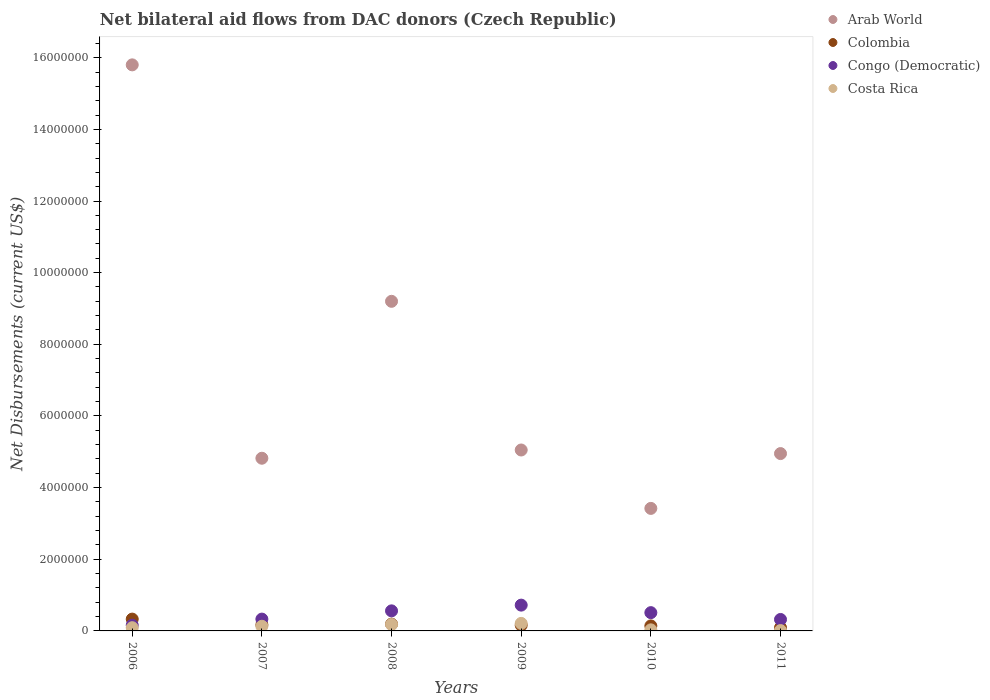What is the net bilateral aid flows in Arab World in 2008?
Offer a very short reply. 9.20e+06. Across all years, what is the maximum net bilateral aid flows in Congo (Democratic)?
Give a very brief answer. 7.20e+05. Across all years, what is the minimum net bilateral aid flows in Arab World?
Your answer should be compact. 3.42e+06. What is the total net bilateral aid flows in Arab World in the graph?
Make the answer very short. 4.32e+07. What is the difference between the net bilateral aid flows in Arab World in 2009 and that in 2011?
Offer a terse response. 1.00e+05. What is the average net bilateral aid flows in Arab World per year?
Give a very brief answer. 7.21e+06. In the year 2006, what is the difference between the net bilateral aid flows in Colombia and net bilateral aid flows in Costa Rica?
Keep it short and to the point. 2.40e+05. Is the difference between the net bilateral aid flows in Colombia in 2008 and 2011 greater than the difference between the net bilateral aid flows in Costa Rica in 2008 and 2011?
Give a very brief answer. No. What is the difference between the highest and the lowest net bilateral aid flows in Congo (Democratic)?
Your answer should be very brief. 5.60e+05. Is it the case that in every year, the sum of the net bilateral aid flows in Costa Rica and net bilateral aid flows in Colombia  is greater than the net bilateral aid flows in Congo (Democratic)?
Keep it short and to the point. No. Does the net bilateral aid flows in Arab World monotonically increase over the years?
Your answer should be very brief. No. How many dotlines are there?
Give a very brief answer. 4. How many years are there in the graph?
Make the answer very short. 6. Are the values on the major ticks of Y-axis written in scientific E-notation?
Ensure brevity in your answer.  No. Does the graph contain any zero values?
Provide a short and direct response. No. Does the graph contain grids?
Your response must be concise. No. What is the title of the graph?
Offer a terse response. Net bilateral aid flows from DAC donors (Czech Republic). What is the label or title of the X-axis?
Provide a short and direct response. Years. What is the label or title of the Y-axis?
Ensure brevity in your answer.  Net Disbursements (current US$). What is the Net Disbursements (current US$) of Arab World in 2006?
Give a very brief answer. 1.58e+07. What is the Net Disbursements (current US$) in Costa Rica in 2006?
Provide a succinct answer. 9.00e+04. What is the Net Disbursements (current US$) in Arab World in 2007?
Your response must be concise. 4.82e+06. What is the Net Disbursements (current US$) of Colombia in 2007?
Offer a terse response. 1.70e+05. What is the Net Disbursements (current US$) in Arab World in 2008?
Make the answer very short. 9.20e+06. What is the Net Disbursements (current US$) in Congo (Democratic) in 2008?
Your response must be concise. 5.60e+05. What is the Net Disbursements (current US$) in Arab World in 2009?
Provide a succinct answer. 5.05e+06. What is the Net Disbursements (current US$) of Colombia in 2009?
Your answer should be very brief. 1.60e+05. What is the Net Disbursements (current US$) in Congo (Democratic) in 2009?
Provide a succinct answer. 7.20e+05. What is the Net Disbursements (current US$) of Costa Rica in 2009?
Your answer should be compact. 2.10e+05. What is the Net Disbursements (current US$) in Arab World in 2010?
Provide a short and direct response. 3.42e+06. What is the Net Disbursements (current US$) in Congo (Democratic) in 2010?
Make the answer very short. 5.10e+05. What is the Net Disbursements (current US$) of Costa Rica in 2010?
Your answer should be very brief. 3.00e+04. What is the Net Disbursements (current US$) in Arab World in 2011?
Your answer should be very brief. 4.95e+06. Across all years, what is the maximum Net Disbursements (current US$) of Arab World?
Provide a succinct answer. 1.58e+07. Across all years, what is the maximum Net Disbursements (current US$) in Colombia?
Your answer should be compact. 3.30e+05. Across all years, what is the maximum Net Disbursements (current US$) of Congo (Democratic)?
Make the answer very short. 7.20e+05. Across all years, what is the minimum Net Disbursements (current US$) in Arab World?
Your response must be concise. 3.42e+06. Across all years, what is the minimum Net Disbursements (current US$) of Colombia?
Give a very brief answer. 9.00e+04. Across all years, what is the minimum Net Disbursements (current US$) in Congo (Democratic)?
Your answer should be compact. 1.60e+05. Across all years, what is the minimum Net Disbursements (current US$) in Costa Rica?
Your response must be concise. 10000. What is the total Net Disbursements (current US$) in Arab World in the graph?
Your answer should be compact. 4.32e+07. What is the total Net Disbursements (current US$) of Colombia in the graph?
Give a very brief answer. 1.08e+06. What is the total Net Disbursements (current US$) of Congo (Democratic) in the graph?
Your response must be concise. 2.60e+06. What is the total Net Disbursements (current US$) of Costa Rica in the graph?
Offer a terse response. 6.50e+05. What is the difference between the Net Disbursements (current US$) in Arab World in 2006 and that in 2007?
Your answer should be compact. 1.10e+07. What is the difference between the Net Disbursements (current US$) in Colombia in 2006 and that in 2007?
Make the answer very short. 1.60e+05. What is the difference between the Net Disbursements (current US$) in Costa Rica in 2006 and that in 2007?
Provide a short and direct response. -4.00e+04. What is the difference between the Net Disbursements (current US$) of Arab World in 2006 and that in 2008?
Provide a short and direct response. 6.60e+06. What is the difference between the Net Disbursements (current US$) in Colombia in 2006 and that in 2008?
Provide a short and direct response. 1.40e+05. What is the difference between the Net Disbursements (current US$) of Congo (Democratic) in 2006 and that in 2008?
Offer a terse response. -4.00e+05. What is the difference between the Net Disbursements (current US$) in Costa Rica in 2006 and that in 2008?
Make the answer very short. -9.00e+04. What is the difference between the Net Disbursements (current US$) of Arab World in 2006 and that in 2009?
Provide a succinct answer. 1.08e+07. What is the difference between the Net Disbursements (current US$) in Colombia in 2006 and that in 2009?
Make the answer very short. 1.70e+05. What is the difference between the Net Disbursements (current US$) in Congo (Democratic) in 2006 and that in 2009?
Your answer should be compact. -5.60e+05. What is the difference between the Net Disbursements (current US$) of Arab World in 2006 and that in 2010?
Provide a succinct answer. 1.24e+07. What is the difference between the Net Disbursements (current US$) in Colombia in 2006 and that in 2010?
Provide a succinct answer. 1.90e+05. What is the difference between the Net Disbursements (current US$) of Congo (Democratic) in 2006 and that in 2010?
Provide a short and direct response. -3.50e+05. What is the difference between the Net Disbursements (current US$) of Costa Rica in 2006 and that in 2010?
Ensure brevity in your answer.  6.00e+04. What is the difference between the Net Disbursements (current US$) of Arab World in 2006 and that in 2011?
Give a very brief answer. 1.08e+07. What is the difference between the Net Disbursements (current US$) in Colombia in 2006 and that in 2011?
Offer a very short reply. 2.40e+05. What is the difference between the Net Disbursements (current US$) of Congo (Democratic) in 2006 and that in 2011?
Your answer should be very brief. -1.60e+05. What is the difference between the Net Disbursements (current US$) in Costa Rica in 2006 and that in 2011?
Provide a succinct answer. 8.00e+04. What is the difference between the Net Disbursements (current US$) in Arab World in 2007 and that in 2008?
Your answer should be compact. -4.38e+06. What is the difference between the Net Disbursements (current US$) of Arab World in 2007 and that in 2009?
Provide a succinct answer. -2.30e+05. What is the difference between the Net Disbursements (current US$) in Colombia in 2007 and that in 2009?
Your answer should be compact. 10000. What is the difference between the Net Disbursements (current US$) in Congo (Democratic) in 2007 and that in 2009?
Your answer should be very brief. -3.90e+05. What is the difference between the Net Disbursements (current US$) in Arab World in 2007 and that in 2010?
Provide a succinct answer. 1.40e+06. What is the difference between the Net Disbursements (current US$) in Colombia in 2007 and that in 2010?
Offer a terse response. 3.00e+04. What is the difference between the Net Disbursements (current US$) in Arab World in 2007 and that in 2011?
Provide a succinct answer. -1.30e+05. What is the difference between the Net Disbursements (current US$) in Colombia in 2007 and that in 2011?
Give a very brief answer. 8.00e+04. What is the difference between the Net Disbursements (current US$) of Arab World in 2008 and that in 2009?
Provide a short and direct response. 4.15e+06. What is the difference between the Net Disbursements (current US$) of Colombia in 2008 and that in 2009?
Your answer should be very brief. 3.00e+04. What is the difference between the Net Disbursements (current US$) of Congo (Democratic) in 2008 and that in 2009?
Your answer should be very brief. -1.60e+05. What is the difference between the Net Disbursements (current US$) of Arab World in 2008 and that in 2010?
Make the answer very short. 5.78e+06. What is the difference between the Net Disbursements (current US$) of Congo (Democratic) in 2008 and that in 2010?
Provide a short and direct response. 5.00e+04. What is the difference between the Net Disbursements (current US$) in Costa Rica in 2008 and that in 2010?
Your answer should be compact. 1.50e+05. What is the difference between the Net Disbursements (current US$) in Arab World in 2008 and that in 2011?
Provide a short and direct response. 4.25e+06. What is the difference between the Net Disbursements (current US$) in Congo (Democratic) in 2008 and that in 2011?
Your response must be concise. 2.40e+05. What is the difference between the Net Disbursements (current US$) of Costa Rica in 2008 and that in 2011?
Provide a short and direct response. 1.70e+05. What is the difference between the Net Disbursements (current US$) of Arab World in 2009 and that in 2010?
Provide a short and direct response. 1.63e+06. What is the difference between the Net Disbursements (current US$) in Colombia in 2009 and that in 2010?
Offer a terse response. 2.00e+04. What is the difference between the Net Disbursements (current US$) of Arab World in 2009 and that in 2011?
Keep it short and to the point. 1.00e+05. What is the difference between the Net Disbursements (current US$) in Congo (Democratic) in 2009 and that in 2011?
Make the answer very short. 4.00e+05. What is the difference between the Net Disbursements (current US$) of Costa Rica in 2009 and that in 2011?
Provide a succinct answer. 2.00e+05. What is the difference between the Net Disbursements (current US$) of Arab World in 2010 and that in 2011?
Provide a short and direct response. -1.53e+06. What is the difference between the Net Disbursements (current US$) in Colombia in 2010 and that in 2011?
Your response must be concise. 5.00e+04. What is the difference between the Net Disbursements (current US$) in Costa Rica in 2010 and that in 2011?
Your answer should be compact. 2.00e+04. What is the difference between the Net Disbursements (current US$) of Arab World in 2006 and the Net Disbursements (current US$) of Colombia in 2007?
Make the answer very short. 1.56e+07. What is the difference between the Net Disbursements (current US$) in Arab World in 2006 and the Net Disbursements (current US$) in Congo (Democratic) in 2007?
Provide a succinct answer. 1.55e+07. What is the difference between the Net Disbursements (current US$) of Arab World in 2006 and the Net Disbursements (current US$) of Costa Rica in 2007?
Your answer should be compact. 1.57e+07. What is the difference between the Net Disbursements (current US$) of Colombia in 2006 and the Net Disbursements (current US$) of Costa Rica in 2007?
Provide a short and direct response. 2.00e+05. What is the difference between the Net Disbursements (current US$) of Arab World in 2006 and the Net Disbursements (current US$) of Colombia in 2008?
Offer a very short reply. 1.56e+07. What is the difference between the Net Disbursements (current US$) in Arab World in 2006 and the Net Disbursements (current US$) in Congo (Democratic) in 2008?
Your response must be concise. 1.52e+07. What is the difference between the Net Disbursements (current US$) of Arab World in 2006 and the Net Disbursements (current US$) of Costa Rica in 2008?
Offer a terse response. 1.56e+07. What is the difference between the Net Disbursements (current US$) in Colombia in 2006 and the Net Disbursements (current US$) in Congo (Democratic) in 2008?
Ensure brevity in your answer.  -2.30e+05. What is the difference between the Net Disbursements (current US$) in Congo (Democratic) in 2006 and the Net Disbursements (current US$) in Costa Rica in 2008?
Provide a short and direct response. -2.00e+04. What is the difference between the Net Disbursements (current US$) of Arab World in 2006 and the Net Disbursements (current US$) of Colombia in 2009?
Your answer should be compact. 1.56e+07. What is the difference between the Net Disbursements (current US$) in Arab World in 2006 and the Net Disbursements (current US$) in Congo (Democratic) in 2009?
Your response must be concise. 1.51e+07. What is the difference between the Net Disbursements (current US$) in Arab World in 2006 and the Net Disbursements (current US$) in Costa Rica in 2009?
Offer a terse response. 1.56e+07. What is the difference between the Net Disbursements (current US$) in Colombia in 2006 and the Net Disbursements (current US$) in Congo (Democratic) in 2009?
Give a very brief answer. -3.90e+05. What is the difference between the Net Disbursements (current US$) of Colombia in 2006 and the Net Disbursements (current US$) of Costa Rica in 2009?
Offer a terse response. 1.20e+05. What is the difference between the Net Disbursements (current US$) in Arab World in 2006 and the Net Disbursements (current US$) in Colombia in 2010?
Make the answer very short. 1.57e+07. What is the difference between the Net Disbursements (current US$) in Arab World in 2006 and the Net Disbursements (current US$) in Congo (Democratic) in 2010?
Your answer should be very brief. 1.53e+07. What is the difference between the Net Disbursements (current US$) of Arab World in 2006 and the Net Disbursements (current US$) of Costa Rica in 2010?
Ensure brevity in your answer.  1.58e+07. What is the difference between the Net Disbursements (current US$) in Colombia in 2006 and the Net Disbursements (current US$) in Congo (Democratic) in 2010?
Give a very brief answer. -1.80e+05. What is the difference between the Net Disbursements (current US$) of Congo (Democratic) in 2006 and the Net Disbursements (current US$) of Costa Rica in 2010?
Provide a short and direct response. 1.30e+05. What is the difference between the Net Disbursements (current US$) in Arab World in 2006 and the Net Disbursements (current US$) in Colombia in 2011?
Provide a short and direct response. 1.57e+07. What is the difference between the Net Disbursements (current US$) of Arab World in 2006 and the Net Disbursements (current US$) of Congo (Democratic) in 2011?
Your answer should be very brief. 1.55e+07. What is the difference between the Net Disbursements (current US$) in Arab World in 2006 and the Net Disbursements (current US$) in Costa Rica in 2011?
Your answer should be compact. 1.58e+07. What is the difference between the Net Disbursements (current US$) of Congo (Democratic) in 2006 and the Net Disbursements (current US$) of Costa Rica in 2011?
Your answer should be compact. 1.50e+05. What is the difference between the Net Disbursements (current US$) of Arab World in 2007 and the Net Disbursements (current US$) of Colombia in 2008?
Your answer should be very brief. 4.63e+06. What is the difference between the Net Disbursements (current US$) in Arab World in 2007 and the Net Disbursements (current US$) in Congo (Democratic) in 2008?
Your answer should be compact. 4.26e+06. What is the difference between the Net Disbursements (current US$) of Arab World in 2007 and the Net Disbursements (current US$) of Costa Rica in 2008?
Provide a short and direct response. 4.64e+06. What is the difference between the Net Disbursements (current US$) of Colombia in 2007 and the Net Disbursements (current US$) of Congo (Democratic) in 2008?
Give a very brief answer. -3.90e+05. What is the difference between the Net Disbursements (current US$) of Arab World in 2007 and the Net Disbursements (current US$) of Colombia in 2009?
Provide a short and direct response. 4.66e+06. What is the difference between the Net Disbursements (current US$) in Arab World in 2007 and the Net Disbursements (current US$) in Congo (Democratic) in 2009?
Make the answer very short. 4.10e+06. What is the difference between the Net Disbursements (current US$) in Arab World in 2007 and the Net Disbursements (current US$) in Costa Rica in 2009?
Provide a succinct answer. 4.61e+06. What is the difference between the Net Disbursements (current US$) in Colombia in 2007 and the Net Disbursements (current US$) in Congo (Democratic) in 2009?
Your response must be concise. -5.50e+05. What is the difference between the Net Disbursements (current US$) of Colombia in 2007 and the Net Disbursements (current US$) of Costa Rica in 2009?
Your response must be concise. -4.00e+04. What is the difference between the Net Disbursements (current US$) in Congo (Democratic) in 2007 and the Net Disbursements (current US$) in Costa Rica in 2009?
Provide a short and direct response. 1.20e+05. What is the difference between the Net Disbursements (current US$) of Arab World in 2007 and the Net Disbursements (current US$) of Colombia in 2010?
Provide a succinct answer. 4.68e+06. What is the difference between the Net Disbursements (current US$) of Arab World in 2007 and the Net Disbursements (current US$) of Congo (Democratic) in 2010?
Keep it short and to the point. 4.31e+06. What is the difference between the Net Disbursements (current US$) of Arab World in 2007 and the Net Disbursements (current US$) of Costa Rica in 2010?
Ensure brevity in your answer.  4.79e+06. What is the difference between the Net Disbursements (current US$) of Colombia in 2007 and the Net Disbursements (current US$) of Congo (Democratic) in 2010?
Provide a short and direct response. -3.40e+05. What is the difference between the Net Disbursements (current US$) in Arab World in 2007 and the Net Disbursements (current US$) in Colombia in 2011?
Give a very brief answer. 4.73e+06. What is the difference between the Net Disbursements (current US$) in Arab World in 2007 and the Net Disbursements (current US$) in Congo (Democratic) in 2011?
Your response must be concise. 4.50e+06. What is the difference between the Net Disbursements (current US$) of Arab World in 2007 and the Net Disbursements (current US$) of Costa Rica in 2011?
Provide a short and direct response. 4.81e+06. What is the difference between the Net Disbursements (current US$) of Colombia in 2007 and the Net Disbursements (current US$) of Congo (Democratic) in 2011?
Keep it short and to the point. -1.50e+05. What is the difference between the Net Disbursements (current US$) in Congo (Democratic) in 2007 and the Net Disbursements (current US$) in Costa Rica in 2011?
Offer a terse response. 3.20e+05. What is the difference between the Net Disbursements (current US$) in Arab World in 2008 and the Net Disbursements (current US$) in Colombia in 2009?
Offer a terse response. 9.04e+06. What is the difference between the Net Disbursements (current US$) of Arab World in 2008 and the Net Disbursements (current US$) of Congo (Democratic) in 2009?
Provide a short and direct response. 8.48e+06. What is the difference between the Net Disbursements (current US$) of Arab World in 2008 and the Net Disbursements (current US$) of Costa Rica in 2009?
Your answer should be very brief. 8.99e+06. What is the difference between the Net Disbursements (current US$) in Colombia in 2008 and the Net Disbursements (current US$) in Congo (Democratic) in 2009?
Provide a succinct answer. -5.30e+05. What is the difference between the Net Disbursements (current US$) of Arab World in 2008 and the Net Disbursements (current US$) of Colombia in 2010?
Keep it short and to the point. 9.06e+06. What is the difference between the Net Disbursements (current US$) in Arab World in 2008 and the Net Disbursements (current US$) in Congo (Democratic) in 2010?
Your answer should be compact. 8.69e+06. What is the difference between the Net Disbursements (current US$) of Arab World in 2008 and the Net Disbursements (current US$) of Costa Rica in 2010?
Keep it short and to the point. 9.17e+06. What is the difference between the Net Disbursements (current US$) of Colombia in 2008 and the Net Disbursements (current US$) of Congo (Democratic) in 2010?
Provide a succinct answer. -3.20e+05. What is the difference between the Net Disbursements (current US$) in Colombia in 2008 and the Net Disbursements (current US$) in Costa Rica in 2010?
Give a very brief answer. 1.60e+05. What is the difference between the Net Disbursements (current US$) of Congo (Democratic) in 2008 and the Net Disbursements (current US$) of Costa Rica in 2010?
Provide a short and direct response. 5.30e+05. What is the difference between the Net Disbursements (current US$) of Arab World in 2008 and the Net Disbursements (current US$) of Colombia in 2011?
Offer a terse response. 9.11e+06. What is the difference between the Net Disbursements (current US$) in Arab World in 2008 and the Net Disbursements (current US$) in Congo (Democratic) in 2011?
Your answer should be compact. 8.88e+06. What is the difference between the Net Disbursements (current US$) in Arab World in 2008 and the Net Disbursements (current US$) in Costa Rica in 2011?
Your answer should be compact. 9.19e+06. What is the difference between the Net Disbursements (current US$) of Colombia in 2008 and the Net Disbursements (current US$) of Congo (Democratic) in 2011?
Your answer should be compact. -1.30e+05. What is the difference between the Net Disbursements (current US$) in Colombia in 2008 and the Net Disbursements (current US$) in Costa Rica in 2011?
Your answer should be very brief. 1.80e+05. What is the difference between the Net Disbursements (current US$) in Congo (Democratic) in 2008 and the Net Disbursements (current US$) in Costa Rica in 2011?
Provide a succinct answer. 5.50e+05. What is the difference between the Net Disbursements (current US$) in Arab World in 2009 and the Net Disbursements (current US$) in Colombia in 2010?
Offer a terse response. 4.91e+06. What is the difference between the Net Disbursements (current US$) in Arab World in 2009 and the Net Disbursements (current US$) in Congo (Democratic) in 2010?
Your answer should be compact. 4.54e+06. What is the difference between the Net Disbursements (current US$) of Arab World in 2009 and the Net Disbursements (current US$) of Costa Rica in 2010?
Ensure brevity in your answer.  5.02e+06. What is the difference between the Net Disbursements (current US$) in Colombia in 2009 and the Net Disbursements (current US$) in Congo (Democratic) in 2010?
Make the answer very short. -3.50e+05. What is the difference between the Net Disbursements (current US$) of Congo (Democratic) in 2009 and the Net Disbursements (current US$) of Costa Rica in 2010?
Provide a succinct answer. 6.90e+05. What is the difference between the Net Disbursements (current US$) in Arab World in 2009 and the Net Disbursements (current US$) in Colombia in 2011?
Provide a short and direct response. 4.96e+06. What is the difference between the Net Disbursements (current US$) of Arab World in 2009 and the Net Disbursements (current US$) of Congo (Democratic) in 2011?
Your response must be concise. 4.73e+06. What is the difference between the Net Disbursements (current US$) in Arab World in 2009 and the Net Disbursements (current US$) in Costa Rica in 2011?
Make the answer very short. 5.04e+06. What is the difference between the Net Disbursements (current US$) of Colombia in 2009 and the Net Disbursements (current US$) of Congo (Democratic) in 2011?
Provide a short and direct response. -1.60e+05. What is the difference between the Net Disbursements (current US$) in Colombia in 2009 and the Net Disbursements (current US$) in Costa Rica in 2011?
Your answer should be compact. 1.50e+05. What is the difference between the Net Disbursements (current US$) in Congo (Democratic) in 2009 and the Net Disbursements (current US$) in Costa Rica in 2011?
Your response must be concise. 7.10e+05. What is the difference between the Net Disbursements (current US$) in Arab World in 2010 and the Net Disbursements (current US$) in Colombia in 2011?
Offer a terse response. 3.33e+06. What is the difference between the Net Disbursements (current US$) of Arab World in 2010 and the Net Disbursements (current US$) of Congo (Democratic) in 2011?
Keep it short and to the point. 3.10e+06. What is the difference between the Net Disbursements (current US$) in Arab World in 2010 and the Net Disbursements (current US$) in Costa Rica in 2011?
Keep it short and to the point. 3.41e+06. What is the average Net Disbursements (current US$) in Arab World per year?
Provide a succinct answer. 7.21e+06. What is the average Net Disbursements (current US$) in Colombia per year?
Make the answer very short. 1.80e+05. What is the average Net Disbursements (current US$) of Congo (Democratic) per year?
Give a very brief answer. 4.33e+05. What is the average Net Disbursements (current US$) of Costa Rica per year?
Your answer should be very brief. 1.08e+05. In the year 2006, what is the difference between the Net Disbursements (current US$) in Arab World and Net Disbursements (current US$) in Colombia?
Give a very brief answer. 1.55e+07. In the year 2006, what is the difference between the Net Disbursements (current US$) of Arab World and Net Disbursements (current US$) of Congo (Democratic)?
Make the answer very short. 1.56e+07. In the year 2006, what is the difference between the Net Disbursements (current US$) in Arab World and Net Disbursements (current US$) in Costa Rica?
Your response must be concise. 1.57e+07. In the year 2007, what is the difference between the Net Disbursements (current US$) in Arab World and Net Disbursements (current US$) in Colombia?
Provide a succinct answer. 4.65e+06. In the year 2007, what is the difference between the Net Disbursements (current US$) in Arab World and Net Disbursements (current US$) in Congo (Democratic)?
Provide a short and direct response. 4.49e+06. In the year 2007, what is the difference between the Net Disbursements (current US$) in Arab World and Net Disbursements (current US$) in Costa Rica?
Ensure brevity in your answer.  4.69e+06. In the year 2007, what is the difference between the Net Disbursements (current US$) in Colombia and Net Disbursements (current US$) in Costa Rica?
Provide a succinct answer. 4.00e+04. In the year 2008, what is the difference between the Net Disbursements (current US$) of Arab World and Net Disbursements (current US$) of Colombia?
Provide a succinct answer. 9.01e+06. In the year 2008, what is the difference between the Net Disbursements (current US$) in Arab World and Net Disbursements (current US$) in Congo (Democratic)?
Offer a very short reply. 8.64e+06. In the year 2008, what is the difference between the Net Disbursements (current US$) of Arab World and Net Disbursements (current US$) of Costa Rica?
Make the answer very short. 9.02e+06. In the year 2008, what is the difference between the Net Disbursements (current US$) in Colombia and Net Disbursements (current US$) in Congo (Democratic)?
Your response must be concise. -3.70e+05. In the year 2008, what is the difference between the Net Disbursements (current US$) of Congo (Democratic) and Net Disbursements (current US$) of Costa Rica?
Your response must be concise. 3.80e+05. In the year 2009, what is the difference between the Net Disbursements (current US$) in Arab World and Net Disbursements (current US$) in Colombia?
Your answer should be compact. 4.89e+06. In the year 2009, what is the difference between the Net Disbursements (current US$) in Arab World and Net Disbursements (current US$) in Congo (Democratic)?
Ensure brevity in your answer.  4.33e+06. In the year 2009, what is the difference between the Net Disbursements (current US$) in Arab World and Net Disbursements (current US$) in Costa Rica?
Provide a succinct answer. 4.84e+06. In the year 2009, what is the difference between the Net Disbursements (current US$) in Colombia and Net Disbursements (current US$) in Congo (Democratic)?
Provide a succinct answer. -5.60e+05. In the year 2009, what is the difference between the Net Disbursements (current US$) in Congo (Democratic) and Net Disbursements (current US$) in Costa Rica?
Your response must be concise. 5.10e+05. In the year 2010, what is the difference between the Net Disbursements (current US$) in Arab World and Net Disbursements (current US$) in Colombia?
Your response must be concise. 3.28e+06. In the year 2010, what is the difference between the Net Disbursements (current US$) of Arab World and Net Disbursements (current US$) of Congo (Democratic)?
Keep it short and to the point. 2.91e+06. In the year 2010, what is the difference between the Net Disbursements (current US$) of Arab World and Net Disbursements (current US$) of Costa Rica?
Your answer should be very brief. 3.39e+06. In the year 2010, what is the difference between the Net Disbursements (current US$) of Colombia and Net Disbursements (current US$) of Congo (Democratic)?
Ensure brevity in your answer.  -3.70e+05. In the year 2010, what is the difference between the Net Disbursements (current US$) of Colombia and Net Disbursements (current US$) of Costa Rica?
Offer a very short reply. 1.10e+05. In the year 2011, what is the difference between the Net Disbursements (current US$) in Arab World and Net Disbursements (current US$) in Colombia?
Your answer should be very brief. 4.86e+06. In the year 2011, what is the difference between the Net Disbursements (current US$) in Arab World and Net Disbursements (current US$) in Congo (Democratic)?
Your response must be concise. 4.63e+06. In the year 2011, what is the difference between the Net Disbursements (current US$) in Arab World and Net Disbursements (current US$) in Costa Rica?
Your answer should be compact. 4.94e+06. What is the ratio of the Net Disbursements (current US$) in Arab World in 2006 to that in 2007?
Provide a succinct answer. 3.28. What is the ratio of the Net Disbursements (current US$) in Colombia in 2006 to that in 2007?
Keep it short and to the point. 1.94. What is the ratio of the Net Disbursements (current US$) in Congo (Democratic) in 2006 to that in 2007?
Your answer should be very brief. 0.48. What is the ratio of the Net Disbursements (current US$) of Costa Rica in 2006 to that in 2007?
Your answer should be compact. 0.69. What is the ratio of the Net Disbursements (current US$) of Arab World in 2006 to that in 2008?
Keep it short and to the point. 1.72. What is the ratio of the Net Disbursements (current US$) of Colombia in 2006 to that in 2008?
Ensure brevity in your answer.  1.74. What is the ratio of the Net Disbursements (current US$) in Congo (Democratic) in 2006 to that in 2008?
Make the answer very short. 0.29. What is the ratio of the Net Disbursements (current US$) in Arab World in 2006 to that in 2009?
Give a very brief answer. 3.13. What is the ratio of the Net Disbursements (current US$) of Colombia in 2006 to that in 2009?
Keep it short and to the point. 2.06. What is the ratio of the Net Disbursements (current US$) in Congo (Democratic) in 2006 to that in 2009?
Offer a terse response. 0.22. What is the ratio of the Net Disbursements (current US$) of Costa Rica in 2006 to that in 2009?
Provide a short and direct response. 0.43. What is the ratio of the Net Disbursements (current US$) in Arab World in 2006 to that in 2010?
Make the answer very short. 4.62. What is the ratio of the Net Disbursements (current US$) of Colombia in 2006 to that in 2010?
Offer a very short reply. 2.36. What is the ratio of the Net Disbursements (current US$) in Congo (Democratic) in 2006 to that in 2010?
Offer a very short reply. 0.31. What is the ratio of the Net Disbursements (current US$) in Arab World in 2006 to that in 2011?
Offer a terse response. 3.19. What is the ratio of the Net Disbursements (current US$) of Colombia in 2006 to that in 2011?
Offer a very short reply. 3.67. What is the ratio of the Net Disbursements (current US$) of Costa Rica in 2006 to that in 2011?
Your response must be concise. 9. What is the ratio of the Net Disbursements (current US$) of Arab World in 2007 to that in 2008?
Give a very brief answer. 0.52. What is the ratio of the Net Disbursements (current US$) of Colombia in 2007 to that in 2008?
Give a very brief answer. 0.89. What is the ratio of the Net Disbursements (current US$) in Congo (Democratic) in 2007 to that in 2008?
Give a very brief answer. 0.59. What is the ratio of the Net Disbursements (current US$) in Costa Rica in 2007 to that in 2008?
Your answer should be very brief. 0.72. What is the ratio of the Net Disbursements (current US$) in Arab World in 2007 to that in 2009?
Your answer should be very brief. 0.95. What is the ratio of the Net Disbursements (current US$) of Congo (Democratic) in 2007 to that in 2009?
Ensure brevity in your answer.  0.46. What is the ratio of the Net Disbursements (current US$) of Costa Rica in 2007 to that in 2009?
Keep it short and to the point. 0.62. What is the ratio of the Net Disbursements (current US$) in Arab World in 2007 to that in 2010?
Keep it short and to the point. 1.41. What is the ratio of the Net Disbursements (current US$) in Colombia in 2007 to that in 2010?
Offer a terse response. 1.21. What is the ratio of the Net Disbursements (current US$) of Congo (Democratic) in 2007 to that in 2010?
Provide a short and direct response. 0.65. What is the ratio of the Net Disbursements (current US$) of Costa Rica in 2007 to that in 2010?
Give a very brief answer. 4.33. What is the ratio of the Net Disbursements (current US$) of Arab World in 2007 to that in 2011?
Ensure brevity in your answer.  0.97. What is the ratio of the Net Disbursements (current US$) of Colombia in 2007 to that in 2011?
Your answer should be very brief. 1.89. What is the ratio of the Net Disbursements (current US$) of Congo (Democratic) in 2007 to that in 2011?
Offer a terse response. 1.03. What is the ratio of the Net Disbursements (current US$) of Arab World in 2008 to that in 2009?
Your response must be concise. 1.82. What is the ratio of the Net Disbursements (current US$) of Colombia in 2008 to that in 2009?
Give a very brief answer. 1.19. What is the ratio of the Net Disbursements (current US$) of Arab World in 2008 to that in 2010?
Offer a very short reply. 2.69. What is the ratio of the Net Disbursements (current US$) of Colombia in 2008 to that in 2010?
Make the answer very short. 1.36. What is the ratio of the Net Disbursements (current US$) in Congo (Democratic) in 2008 to that in 2010?
Keep it short and to the point. 1.1. What is the ratio of the Net Disbursements (current US$) in Costa Rica in 2008 to that in 2010?
Provide a succinct answer. 6. What is the ratio of the Net Disbursements (current US$) of Arab World in 2008 to that in 2011?
Offer a very short reply. 1.86. What is the ratio of the Net Disbursements (current US$) in Colombia in 2008 to that in 2011?
Offer a very short reply. 2.11. What is the ratio of the Net Disbursements (current US$) in Arab World in 2009 to that in 2010?
Provide a succinct answer. 1.48. What is the ratio of the Net Disbursements (current US$) in Colombia in 2009 to that in 2010?
Your answer should be compact. 1.14. What is the ratio of the Net Disbursements (current US$) of Congo (Democratic) in 2009 to that in 2010?
Provide a short and direct response. 1.41. What is the ratio of the Net Disbursements (current US$) of Arab World in 2009 to that in 2011?
Provide a succinct answer. 1.02. What is the ratio of the Net Disbursements (current US$) in Colombia in 2009 to that in 2011?
Provide a short and direct response. 1.78. What is the ratio of the Net Disbursements (current US$) of Congo (Democratic) in 2009 to that in 2011?
Your answer should be very brief. 2.25. What is the ratio of the Net Disbursements (current US$) of Costa Rica in 2009 to that in 2011?
Give a very brief answer. 21. What is the ratio of the Net Disbursements (current US$) of Arab World in 2010 to that in 2011?
Make the answer very short. 0.69. What is the ratio of the Net Disbursements (current US$) in Colombia in 2010 to that in 2011?
Provide a succinct answer. 1.56. What is the ratio of the Net Disbursements (current US$) in Congo (Democratic) in 2010 to that in 2011?
Ensure brevity in your answer.  1.59. What is the difference between the highest and the second highest Net Disbursements (current US$) of Arab World?
Offer a terse response. 6.60e+06. What is the difference between the highest and the lowest Net Disbursements (current US$) in Arab World?
Ensure brevity in your answer.  1.24e+07. What is the difference between the highest and the lowest Net Disbursements (current US$) of Colombia?
Provide a short and direct response. 2.40e+05. What is the difference between the highest and the lowest Net Disbursements (current US$) of Congo (Democratic)?
Provide a short and direct response. 5.60e+05. 